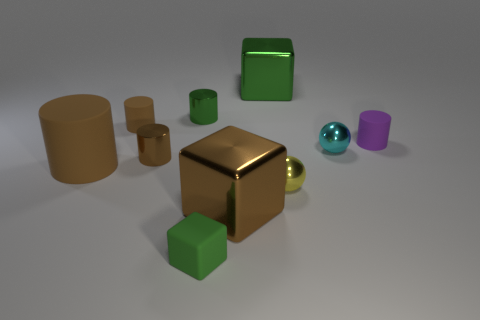Imagine these objects are part of a puzzle, how would you describe the challenge? If we envision these objects as part of a puzzle, the challenge could involve sorting them by size or material, or perhaps arranging them to fit within a particular space. With varying sizes and shapes on display, the puzzle might require spatial reasoning to determine how they can all interlock or balance together in a specific arrangement. 